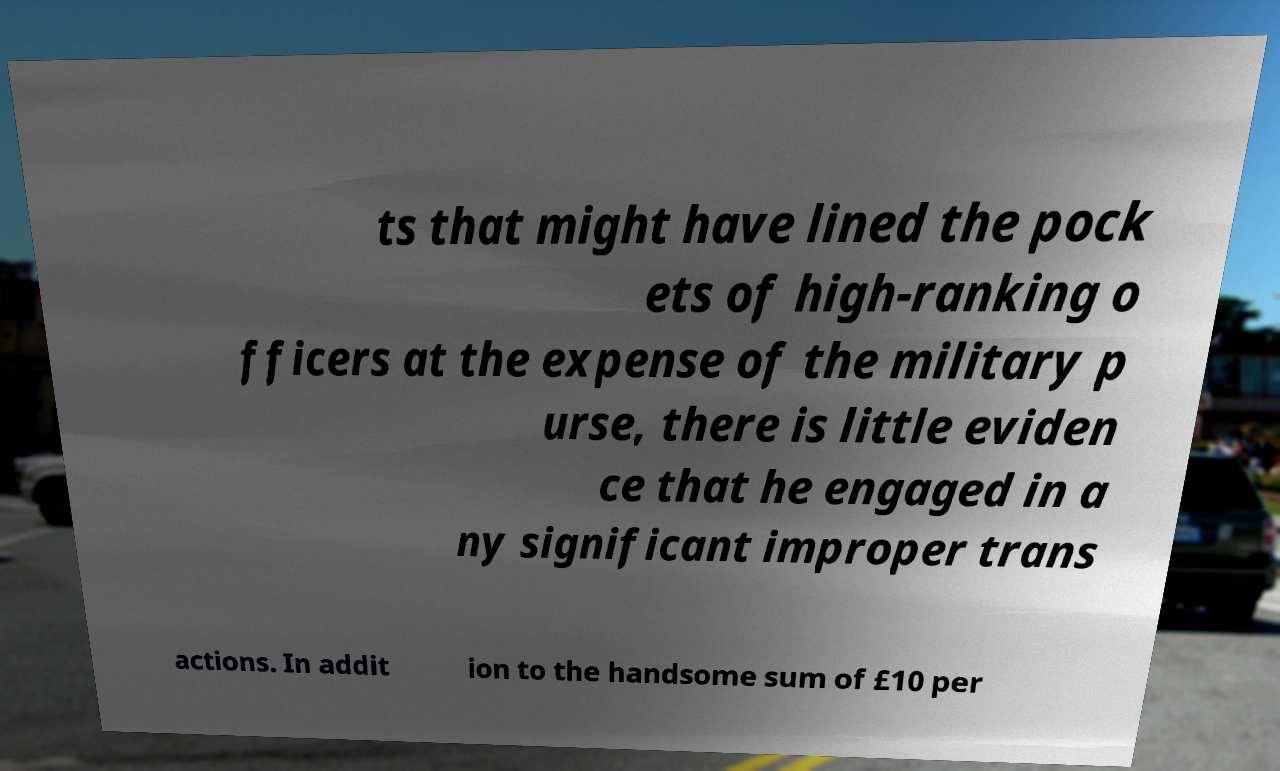For documentation purposes, I need the text within this image transcribed. Could you provide that? ts that might have lined the pock ets of high-ranking o fficers at the expense of the military p urse, there is little eviden ce that he engaged in a ny significant improper trans actions. In addit ion to the handsome sum of £10 per 